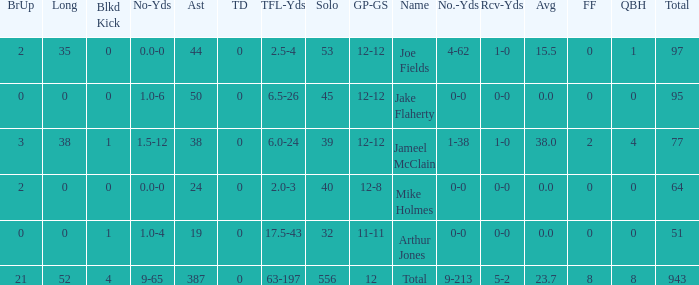How many yards for the player with tfl-yds of 2.5-4? 4-62. 